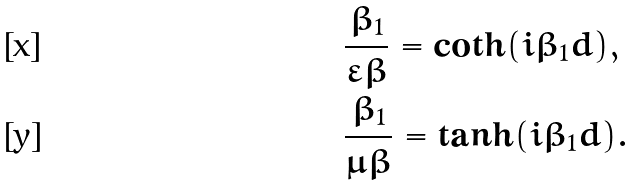Convert formula to latex. <formula><loc_0><loc_0><loc_500><loc_500>& \frac { \beta _ { 1 } } { \varepsilon \beta } = \coth ( i \beta _ { 1 } d ) , \\ & \frac { \beta _ { 1 } } { \mu \beta } = \tanh ( i \beta _ { 1 } d ) .</formula> 